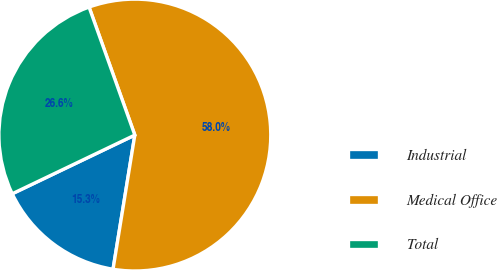Convert chart. <chart><loc_0><loc_0><loc_500><loc_500><pie_chart><fcel>Industrial<fcel>Medical Office<fcel>Total<nl><fcel>15.33%<fcel>58.03%<fcel>26.64%<nl></chart> 